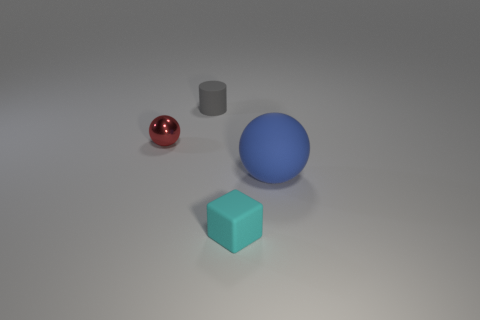Is there anything else that is made of the same material as the tiny red sphere?
Make the answer very short. No. There is a sphere in front of the shiny sphere; does it have the same size as the gray matte object?
Give a very brief answer. No. Are there any things that are on the right side of the sphere to the left of the tiny object behind the small shiny object?
Offer a terse response. Yes. Are there any objects on the right side of the gray matte thing?
Your answer should be compact. Yes. Are there any tiny spheres of the same color as the rubber cube?
Provide a short and direct response. No. How many tiny things are cylinders or brown shiny blocks?
Offer a terse response. 1. Does the tiny thing behind the red metal ball have the same material as the big blue thing?
Give a very brief answer. Yes. What shape is the thing that is behind the small object that is on the left side of the rubber object that is behind the tiny metallic sphere?
Offer a terse response. Cylinder. What number of blue things are spheres or cylinders?
Your answer should be very brief. 1. Are there an equal number of gray cylinders to the right of the large blue matte sphere and blue matte objects on the left side of the red metal thing?
Offer a terse response. Yes. 